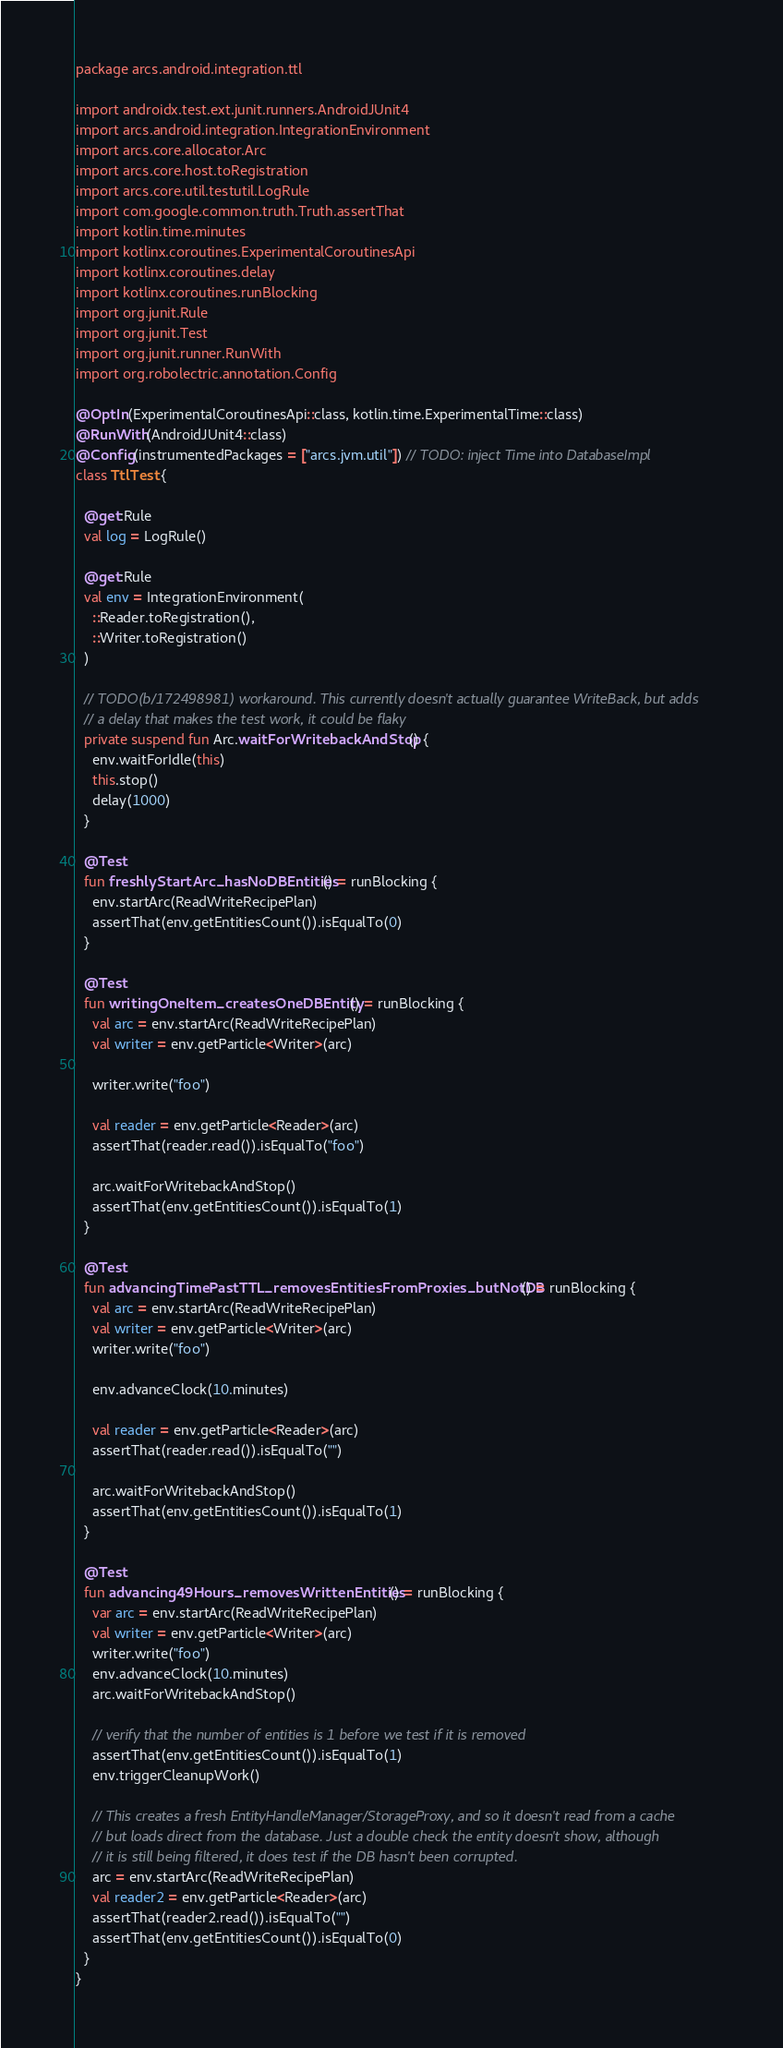<code> <loc_0><loc_0><loc_500><loc_500><_Kotlin_>package arcs.android.integration.ttl

import androidx.test.ext.junit.runners.AndroidJUnit4
import arcs.android.integration.IntegrationEnvironment
import arcs.core.allocator.Arc
import arcs.core.host.toRegistration
import arcs.core.util.testutil.LogRule
import com.google.common.truth.Truth.assertThat
import kotlin.time.minutes
import kotlinx.coroutines.ExperimentalCoroutinesApi
import kotlinx.coroutines.delay
import kotlinx.coroutines.runBlocking
import org.junit.Rule
import org.junit.Test
import org.junit.runner.RunWith
import org.robolectric.annotation.Config

@OptIn(ExperimentalCoroutinesApi::class, kotlin.time.ExperimentalTime::class)
@RunWith(AndroidJUnit4::class)
@Config(instrumentedPackages = ["arcs.jvm.util"]) // TODO: inject Time into DatabaseImpl
class TtlTest {

  @get:Rule
  val log = LogRule()

  @get:Rule
  val env = IntegrationEnvironment(
    ::Reader.toRegistration(),
    ::Writer.toRegistration()
  )

  // TODO(b/172498981) workaround. This currently doesn't actually guarantee WriteBack, but adds
  // a delay that makes the test work, it could be flaky
  private suspend fun Arc.waitForWritebackAndStop() {
    env.waitForIdle(this)
    this.stop()
    delay(1000)
  }

  @Test
  fun freshlyStartArc_hasNoDBEntities() = runBlocking {
    env.startArc(ReadWriteRecipePlan)
    assertThat(env.getEntitiesCount()).isEqualTo(0)
  }

  @Test
  fun writingOneItem_createsOneDBEntity() = runBlocking {
    val arc = env.startArc(ReadWriteRecipePlan)
    val writer = env.getParticle<Writer>(arc)

    writer.write("foo")

    val reader = env.getParticle<Reader>(arc)
    assertThat(reader.read()).isEqualTo("foo")

    arc.waitForWritebackAndStop()
    assertThat(env.getEntitiesCount()).isEqualTo(1)
  }

  @Test
  fun advancingTimePastTTL_removesEntitiesFromProxies_butNotDB() = runBlocking {
    val arc = env.startArc(ReadWriteRecipePlan)
    val writer = env.getParticle<Writer>(arc)
    writer.write("foo")

    env.advanceClock(10.minutes)

    val reader = env.getParticle<Reader>(arc)
    assertThat(reader.read()).isEqualTo("")

    arc.waitForWritebackAndStop()
    assertThat(env.getEntitiesCount()).isEqualTo(1)
  }

  @Test
  fun advancing49Hours_removesWrittenEntities() = runBlocking {
    var arc = env.startArc(ReadWriteRecipePlan)
    val writer = env.getParticle<Writer>(arc)
    writer.write("foo")
    env.advanceClock(10.minutes)
    arc.waitForWritebackAndStop()

    // verify that the number of entities is 1 before we test if it is removed
    assertThat(env.getEntitiesCount()).isEqualTo(1)
    env.triggerCleanupWork()

    // This creates a fresh EntityHandleManager/StorageProxy, and so it doesn't read from a cache
    // but loads direct from the database. Just a double check the entity doesn't show, although
    // it is still being filtered, it does test if the DB hasn't been corrupted.
    arc = env.startArc(ReadWriteRecipePlan)
    val reader2 = env.getParticle<Reader>(arc)
    assertThat(reader2.read()).isEqualTo("")
    assertThat(env.getEntitiesCount()).isEqualTo(0)
  }
}
</code> 